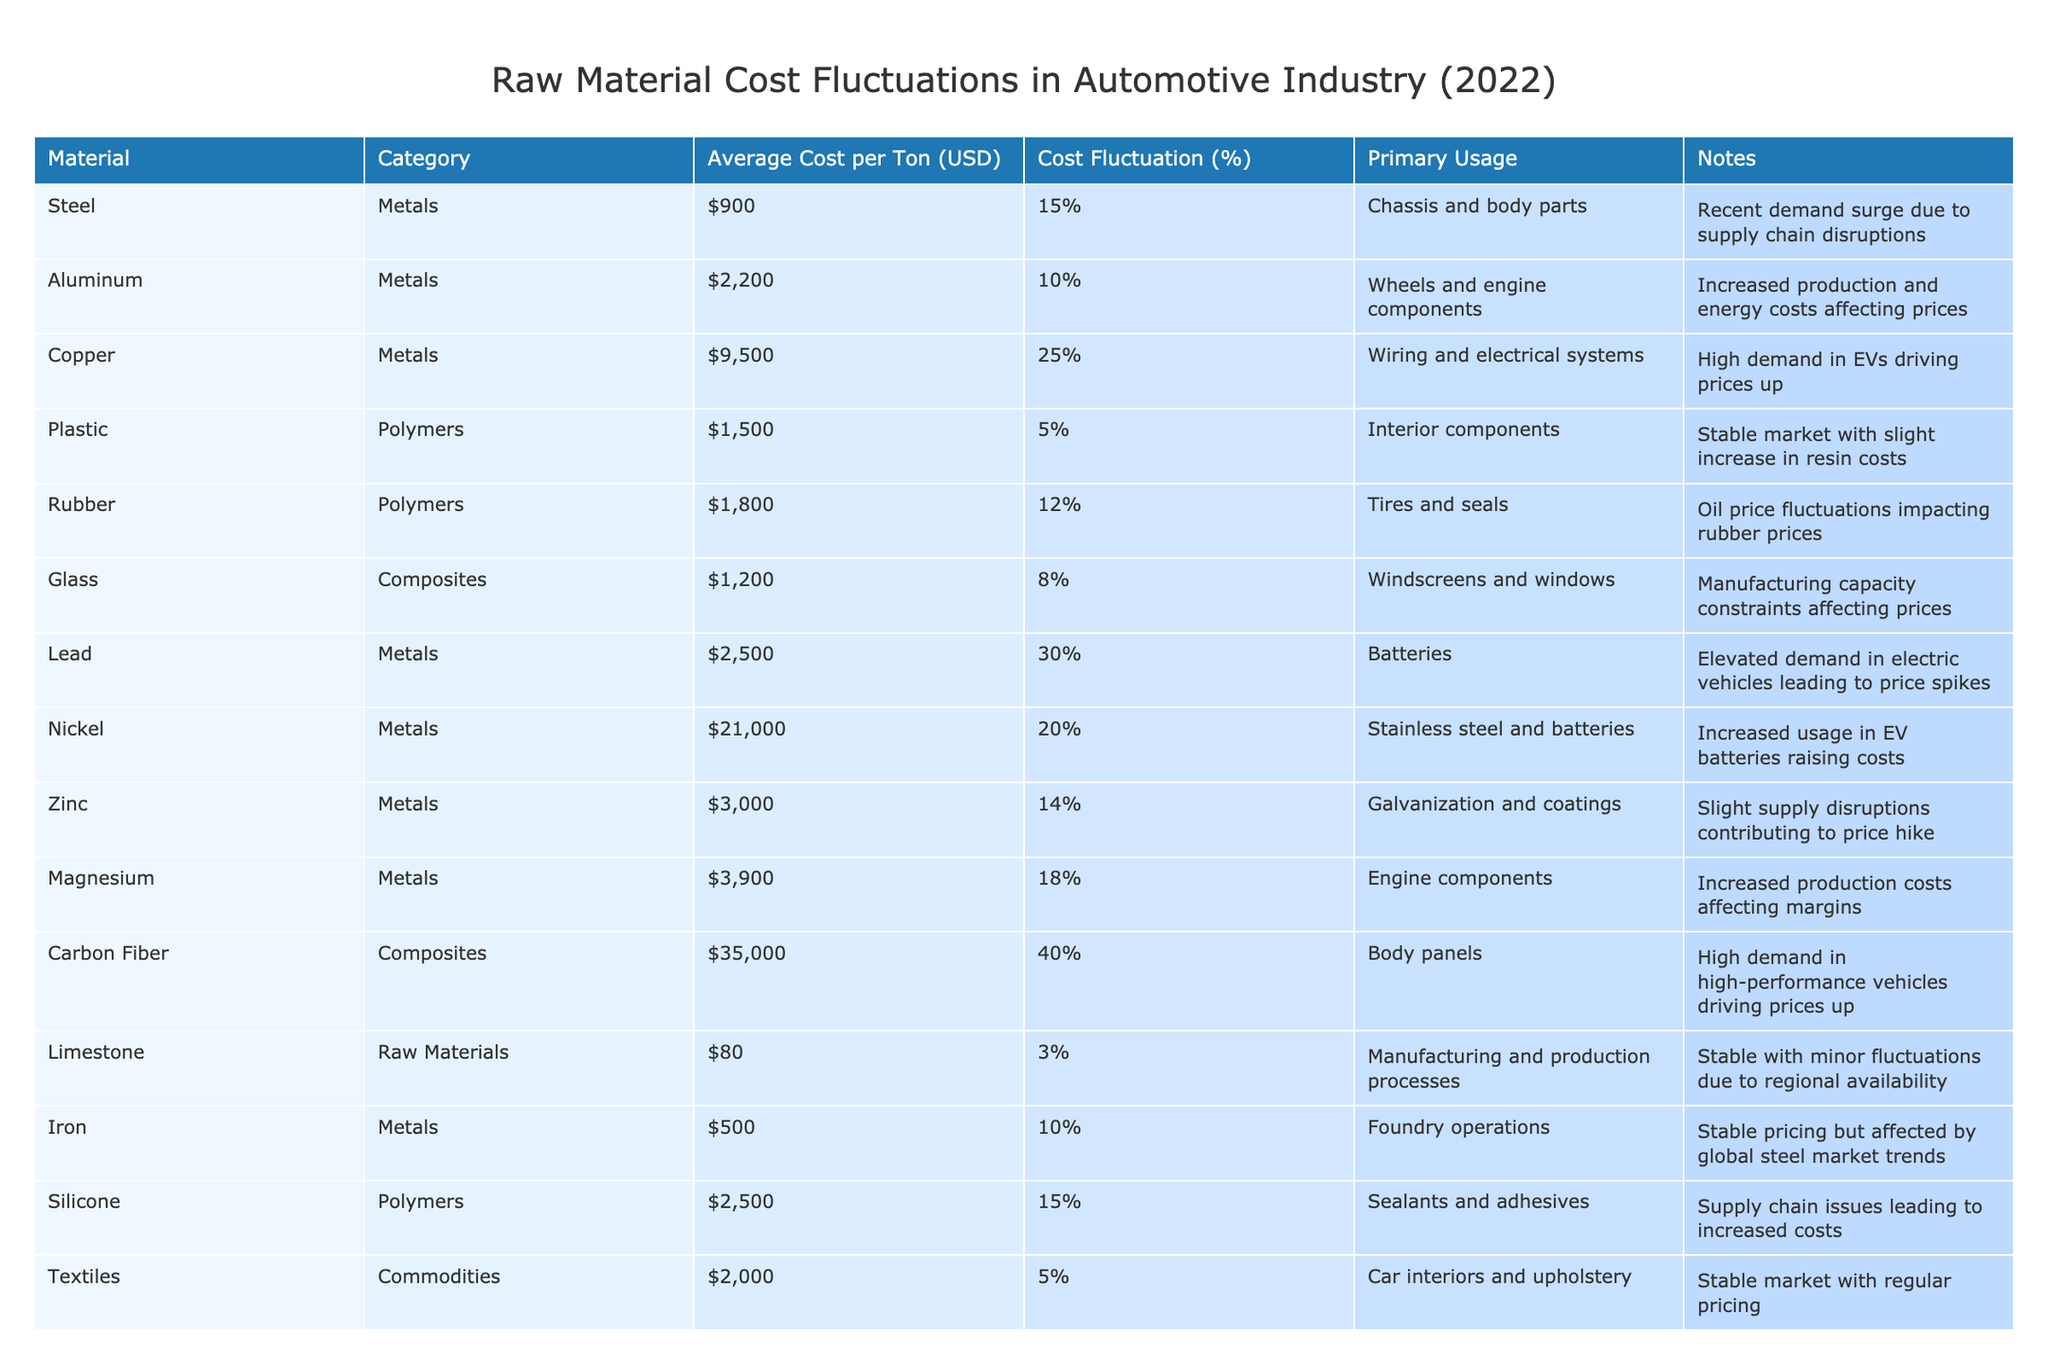What is the average cost per ton of Copper? The table lists the average cost per ton of Copper as 9,500 USD. This is a direct retrieval from the specified row for Copper.
Answer: 9,500 USD Which material has the highest cost fluctuation percentage? By examining the Cost Fluctuation column, the table indicates that Carbon Fiber has the highest fluctuation at 40%. This requires identifying all percentages and comparing them.
Answer: Carbon Fiber What is the total average cost of all the metals listed? The average costs for steel, aluminum, copper, lead, nickel, zinc, magnesium, iron, and chrome are added together: 900 + 2200 + 9500 + 2500 + 21000 + 3000 + 3900 + 500 + 15000 = 58,500 USD. Therefore, the total average cost of all metals is calculated through summation.
Answer: 58,500 USD Did any raw materials have a cost fluctuation percentage greater than 20%? By reviewing the Cost Fluctuation column, it's clear that Copper (25%), Lead (30%), Nickel (20%), and Carbon Fiber (40%) all exceed 20%. This involves checking individual values against the threshold.
Answer: Yes Which polymer has the most stable average cost based on percentage fluctuations? When looking at the table, Plastic shows a cost fluctuation of only 5%, while Rubber has 12% and Silicone has 15%. Thus, Plastic is identified as the most stable polymer by finding the minimum percentage fluctuation.
Answer: Plastic 